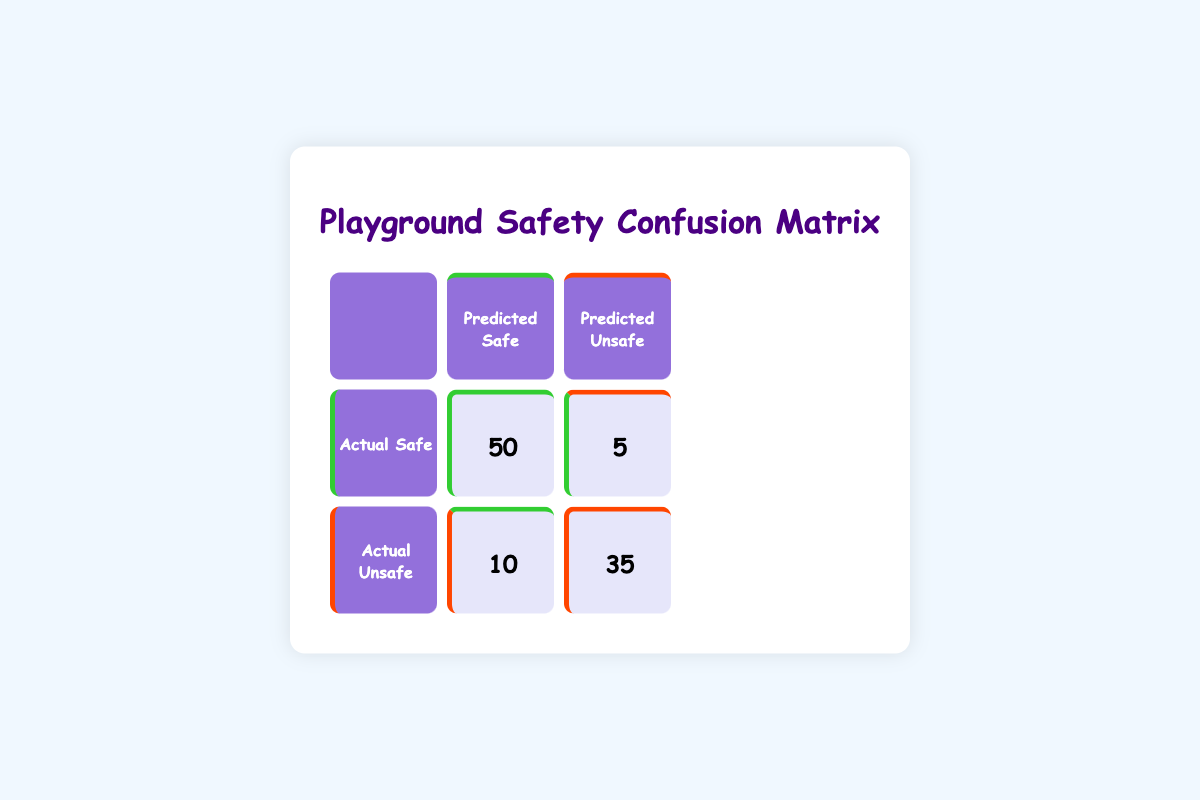What is the count of actual Safe activities predicted as Safe? The table shows the count in the cell for actual Safe and predicted Safe, which is 50.
Answer: 50 What is the count of actual Unsafe activities predicted as Unsafe? The table shows the count in the cell for actual Unsafe and predicted Unsafe, which is 35.
Answer: 35 How many activities were incorrectly predicted as Safe when they were actually Unsafe? This count corresponds to the cell for actual Unsafe and predicted Safe, which is 10.
Answer: 10 What is the total number of Safe activities recorded? To find this, we sum the values for actual Safe, which are 50 and 5. So, 50 + 5 equals 55.
Answer: 55 Is it true that there were more Safe activities than Unsafe activities predicted as Unsafe? We compare the counts for Safe predicted as Unsafe (5) and Unsafe predicted as Unsafe (35). Since 35 is greater, the statement is false.
Answer: No What percentage of all Unsafe activities were correctly identified as Unsafe? The total number of actual Unsafe activities is 10 (predicted as Safe) plus 35 (predicted as Unsafe), which equals 45. The number correctly identified as Unsafe is 35. So, the percentage is (35/45) * 100, which is approximately 77.78%.
Answer: 77.78% If we add the total number of predicted Safe and predicted Unsafe activities, what is the total? The predicted Safe count is 50 (actual Safe) plus 10 (actual Unsafe), which equals 60. The predicted Unsafe count is 5 (actual Safe) plus 35 (actual Unsafe), which equals 40. Adding them gives 60 + 40 equals 100.
Answer: 100 How many total predictions were made in this analysis? The total predictions are calculated by summing all values in the confusion matrix: 50 + 5 + 10 + 35, which equals 100.
Answer: 100 What is the count of actual Safe activities that were incorrectly predicted as Unsafe? This corresponds to the cell for actual Safe and predicted Unsafe, which shows a count of 5.
Answer: 5 